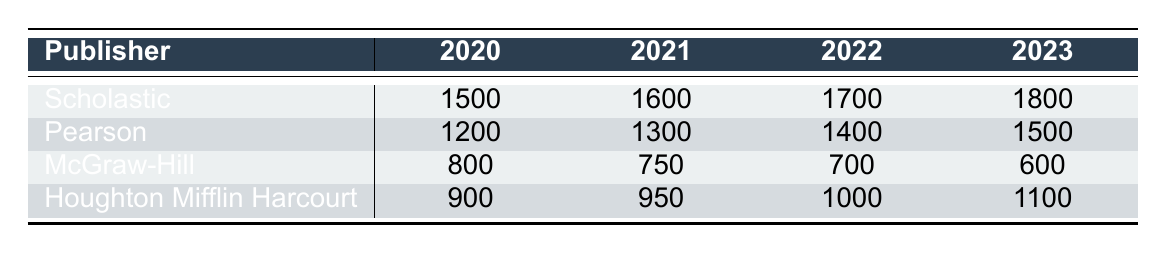What is the inventory level of Scholastic in 2021? The table shows that Scholastic has an inventory level of 1600 in the year 2021.
Answer: 1600 Which publisher had the highest inventory level in 2020? By comparing the inventory levels for each publisher in 2020, Scholastic has the highest amount, which is 1500, compared to Pearson (1200), McGraw-Hill (800), and Houghton Mifflin Harcourt (900).
Answer: Scholastic What is the total inventory level for McGraw-Hill from 2020 to 2023? The inventory levels for McGraw-Hill are 800 in 2020, 750 in 2021, 700 in 2022, and 600 in 2023. Adding these together: 800 + 750 + 700 + 600 = 2850 yields a total inventory of 2850.
Answer: 2850 Did Houghton Mifflin Harcourt's inventory increase every year from 2020 to 2023? The inventory levels for Houghton Mifflin Harcourt are 900 in 2020, 950 in 2021, 1000 in 2022, and 1100 in 2023, showing consistent increases each year. Therefore, yes, the inventory increased every year.
Answer: Yes What was the percentage increase in inventory for Pearson from 2020 to 2023? Pearson's inventory was 1200 in 2020 and 1500 in 2023. The increase is 1500 - 1200 = 300. To find the percentage increase, we divide the increase by the original amount and multiply by 100: (300 / 1200) * 100 = 25%.
Answer: 25% 